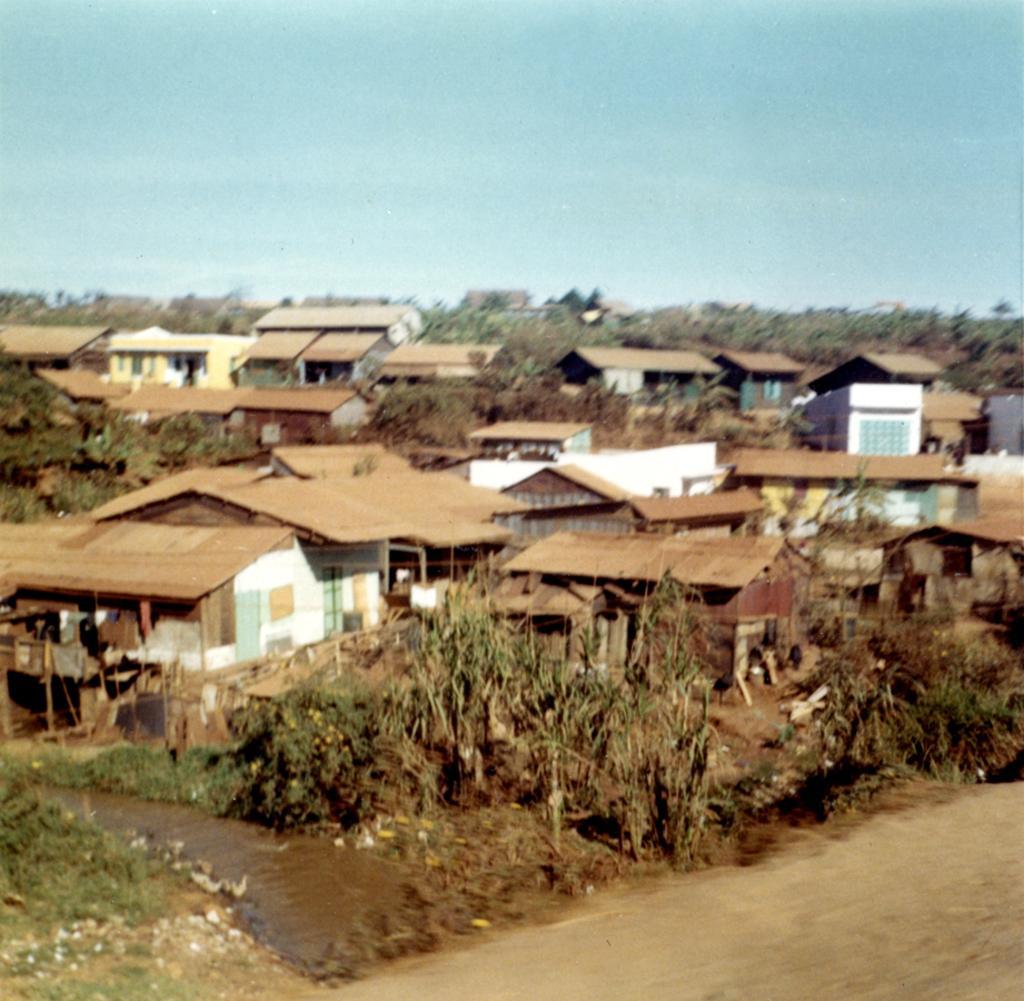In one or two sentences, can you explain what this image depicts? This image is slightly blurred, where we can see trees, houses, road and the sky in the background. 